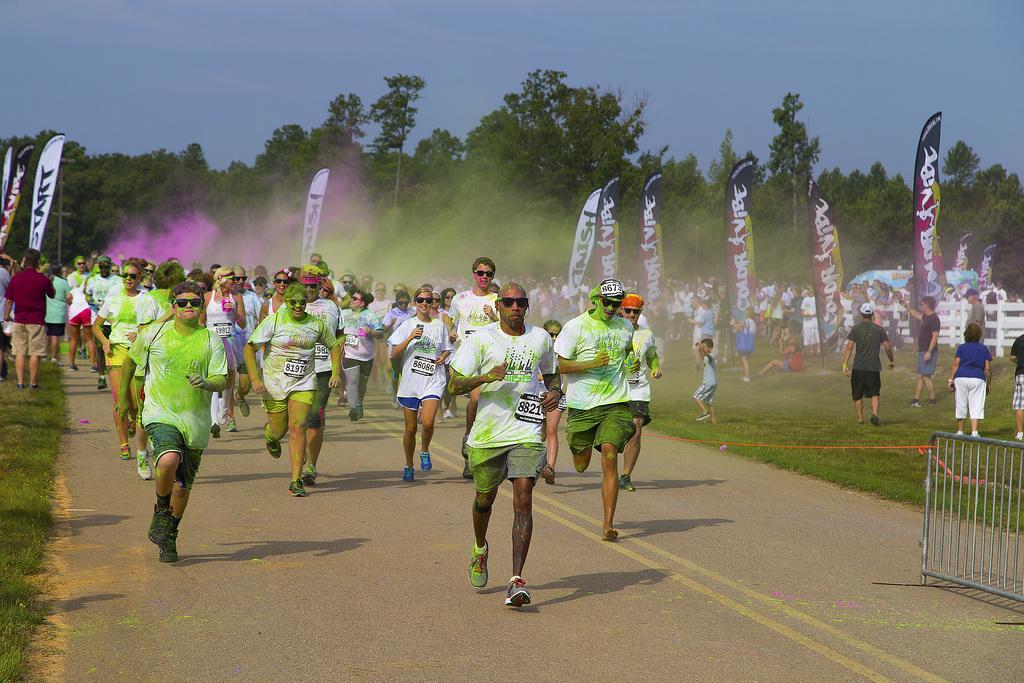Can you describe this image briefly? In this image there is the sky truncated towards the top of the image, there are trees truncated, there are flags, the flags are truncated towards the left of the image, there is grass truncated towards the left of the image, there is the grass truncated towards the right of the image, there is fencing truncated towards the right of the image, there are persons running, there is road truncated truncated towards the bottom of the image, there are persons standing, there is a person sitting on the grass. 